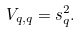<formula> <loc_0><loc_0><loc_500><loc_500>V _ { q , q } = s _ { q } ^ { 2 } .</formula> 